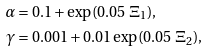Convert formula to latex. <formula><loc_0><loc_0><loc_500><loc_500>\alpha & = 0 . 1 + \exp ( 0 . 0 5 \ \Xi _ { 1 } ) , \\ \gamma & = 0 . 0 0 1 + 0 . 0 1 \exp ( 0 . 0 5 \ \Xi _ { 2 } ) ,</formula> 